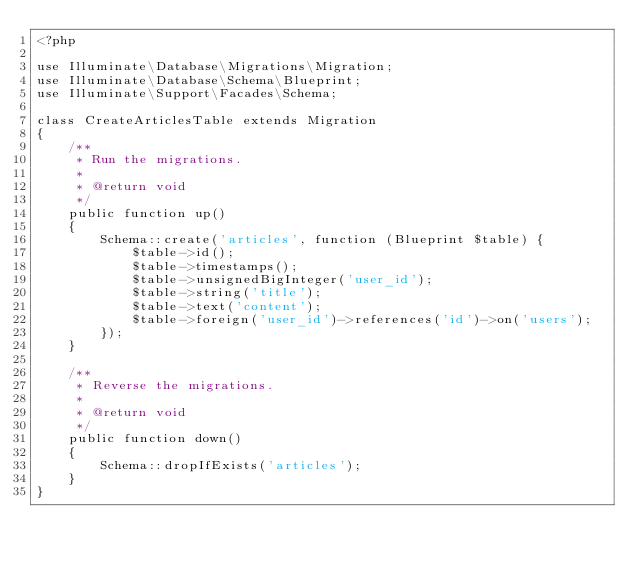Convert code to text. <code><loc_0><loc_0><loc_500><loc_500><_PHP_><?php

use Illuminate\Database\Migrations\Migration;
use Illuminate\Database\Schema\Blueprint;
use Illuminate\Support\Facades\Schema;

class CreateArticlesTable extends Migration
{
    /**
     * Run the migrations.
     *
     * @return void
     */
    public function up()
    {
        Schema::create('articles', function (Blueprint $table) {
            $table->id();
            $table->timestamps();
            $table->unsignedBigInteger('user_id');
            $table->string('title');
            $table->text('content');
            $table->foreign('user_id')->references('id')->on('users');
        });
    }

    /**
     * Reverse the migrations.
     *
     * @return void
     */
    public function down()
    {
        Schema::dropIfExists('articles');
    }
}
</code> 